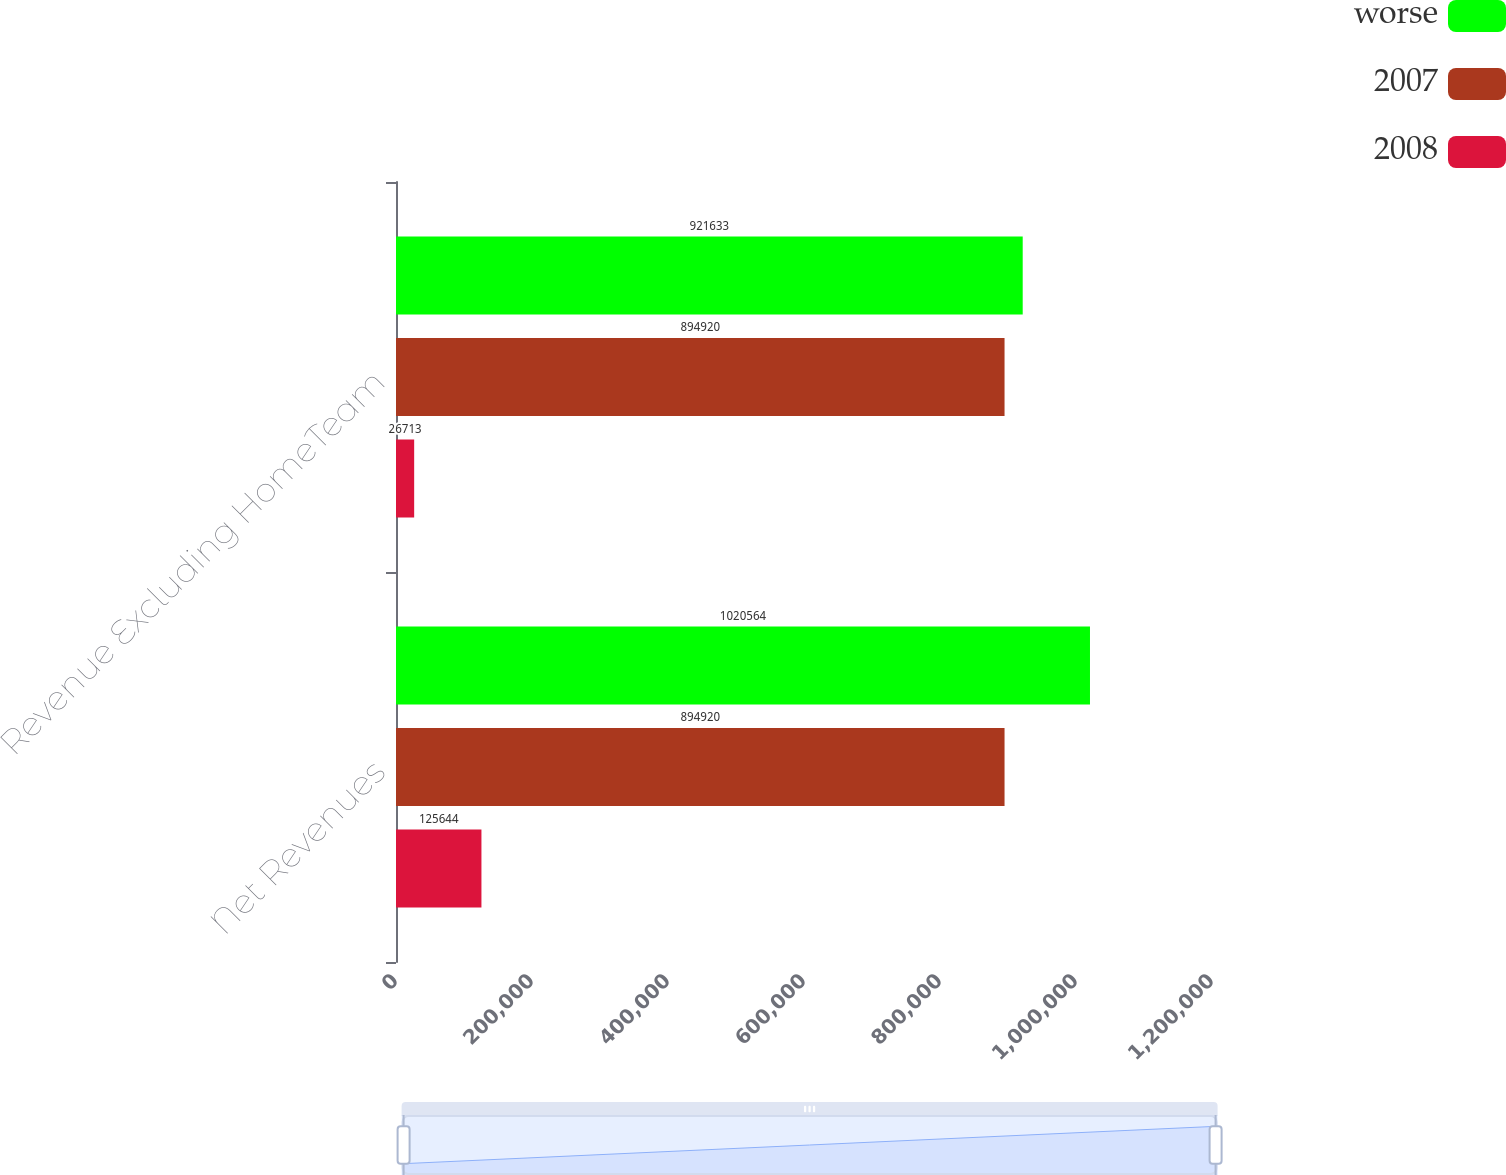<chart> <loc_0><loc_0><loc_500><loc_500><stacked_bar_chart><ecel><fcel>Net Revenues<fcel>Revenue Excluding HomeTeam<nl><fcel>worse<fcel>1.02056e+06<fcel>921633<nl><fcel>2007<fcel>894920<fcel>894920<nl><fcel>2008<fcel>125644<fcel>26713<nl></chart> 